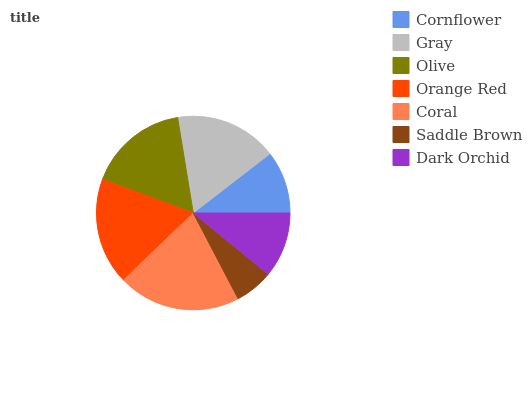Is Saddle Brown the minimum?
Answer yes or no. Yes. Is Coral the maximum?
Answer yes or no. Yes. Is Gray the minimum?
Answer yes or no. No. Is Gray the maximum?
Answer yes or no. No. Is Gray greater than Cornflower?
Answer yes or no. Yes. Is Cornflower less than Gray?
Answer yes or no. Yes. Is Cornflower greater than Gray?
Answer yes or no. No. Is Gray less than Cornflower?
Answer yes or no. No. Is Olive the high median?
Answer yes or no. Yes. Is Olive the low median?
Answer yes or no. Yes. Is Dark Orchid the high median?
Answer yes or no. No. Is Saddle Brown the low median?
Answer yes or no. No. 